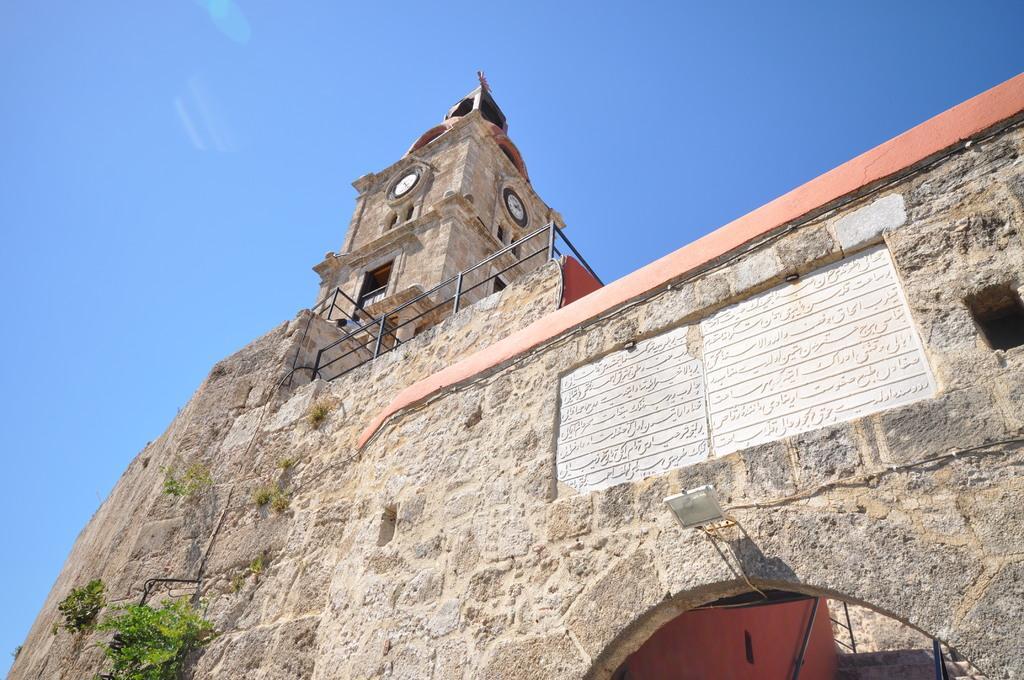In one or two sentences, can you explain what this image depicts? In this picture I can see there is a building here and there is a tower, it has a clock and there is a rock here and there is something written on it. There are some plants on the building and the sky is clear. 